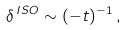<formula> <loc_0><loc_0><loc_500><loc_500>\delta ^ { \, I S O } \sim ( - t ) ^ { - 1 } \, ,</formula> 